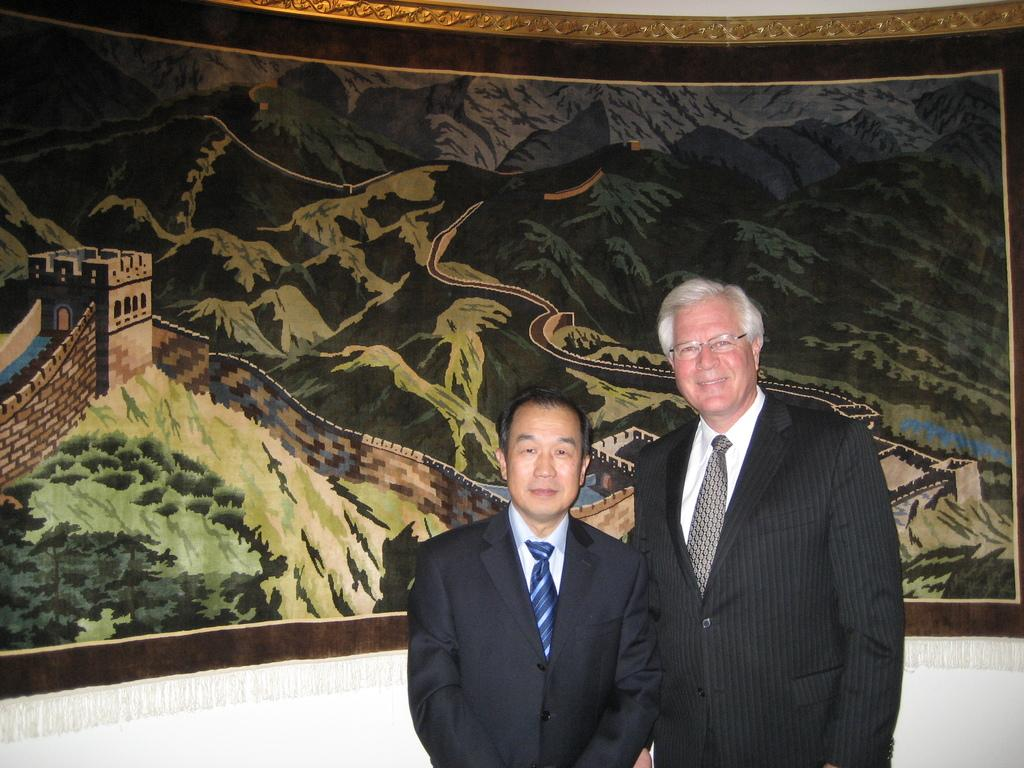How many people are in the image? There are two people in the image. What are the people wearing? The people are wearing coats. What are the people doing in the image? The people are standing. What can be seen in the background of the image? There is a printed design curtain in the background of the image. What time of day is it in the image, based on the hour? There is no information about the time of day or hour in the image, so it cannot be determined. 